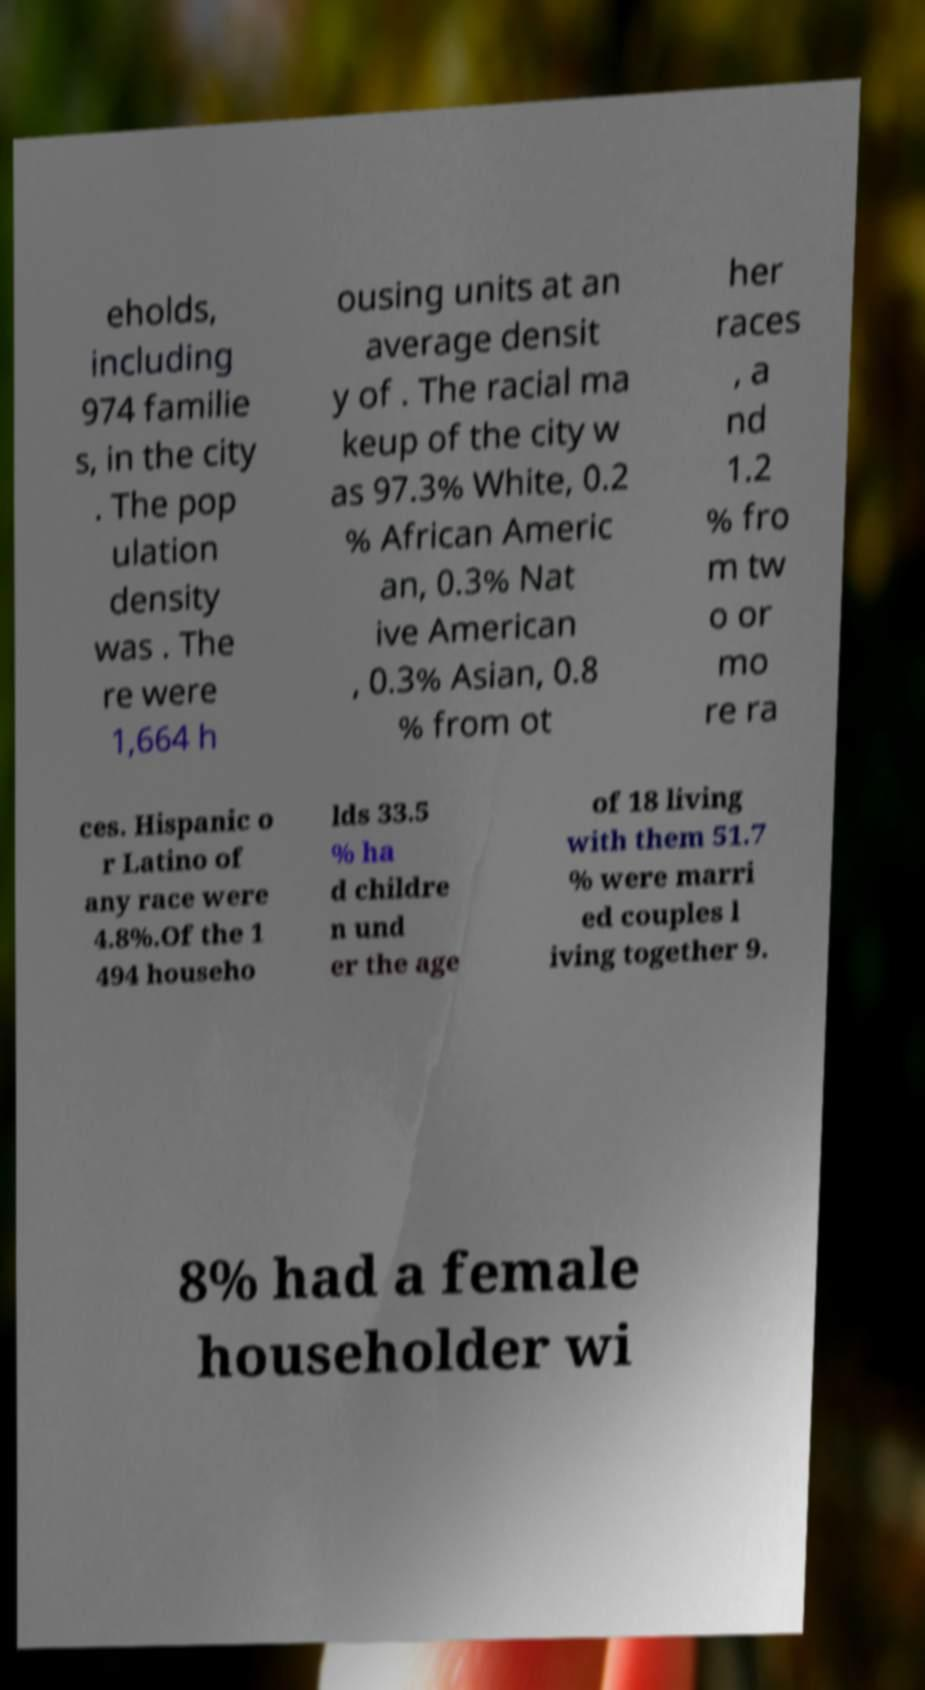Could you assist in decoding the text presented in this image and type it out clearly? eholds, including 974 familie s, in the city . The pop ulation density was . The re were 1,664 h ousing units at an average densit y of . The racial ma keup of the city w as 97.3% White, 0.2 % African Americ an, 0.3% Nat ive American , 0.3% Asian, 0.8 % from ot her races , a nd 1.2 % fro m tw o or mo re ra ces. Hispanic o r Latino of any race were 4.8%.Of the 1 494 househo lds 33.5 % ha d childre n und er the age of 18 living with them 51.7 % were marri ed couples l iving together 9. 8% had a female householder wi 